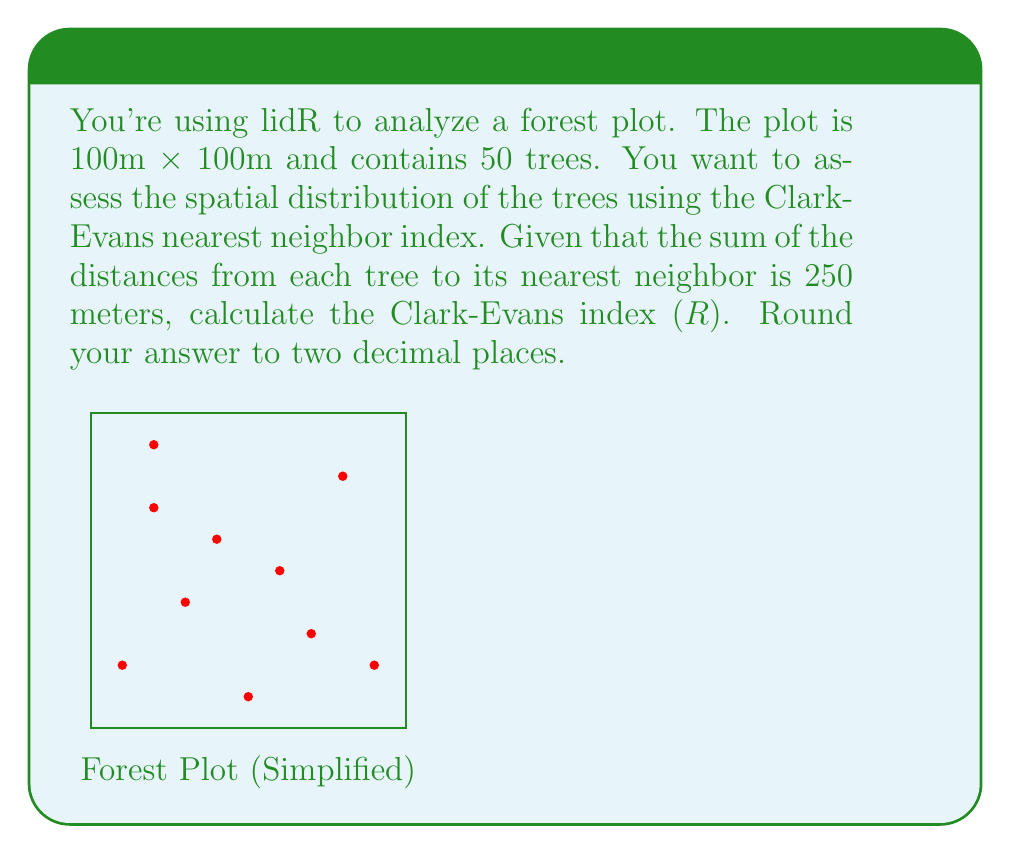What is the answer to this math problem? Let's approach this step-by-step:

1) The Clark-Evans index (R) is calculated using the formula:

   $$R = \frac{\bar{r}_A}{\bar{r}_E}$$

   where $\bar{r}_A$ is the observed mean nearest neighbor distance, and $\bar{r}_E$ is the expected mean nearest neighbor distance in a random distribution.

2) We can calculate $\bar{r}_A$ by dividing the sum of nearest neighbor distances by the number of trees:

   $$\bar{r}_A = \frac{250}{50} = 5\text{ meters}$$

3) To calculate $\bar{r}_E$, we use the formula:

   $$\bar{r}_E = \frac{1}{2\sqrt{\lambda}}$$

   where $\lambda$ is the density of trees per unit area.

4) The density $\lambda$ is the number of trees divided by the area:

   $$\lambda = \frac{50}{100 \times 100} = 0.005\text{ trees/m}^2$$

5) Now we can calculate $\bar{r}_E$:

   $$\bar{r}_E = \frac{1}{2\sqrt{0.005}} \approx 7.0711\text{ meters}$$

6) Finally, we can calculate R:

   $$R = \frac{5}{7.0711} \approx 0.7071$$

7) Rounding to two decimal places, we get 0.71.
Answer: 0.71 